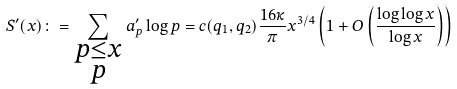<formula> <loc_0><loc_0><loc_500><loc_500>S ^ { \prime } ( x ) \colon = \sum _ { \substack { p \leq x \\ p } } a ^ { \prime } _ { p } \log p = c ( q _ { 1 } , q _ { 2 } ) \frac { 1 6 \kappa } { \pi } x ^ { 3 / 4 } \left ( 1 + O \left ( \frac { \log \log x } { \log x } \right ) \right )</formula> 